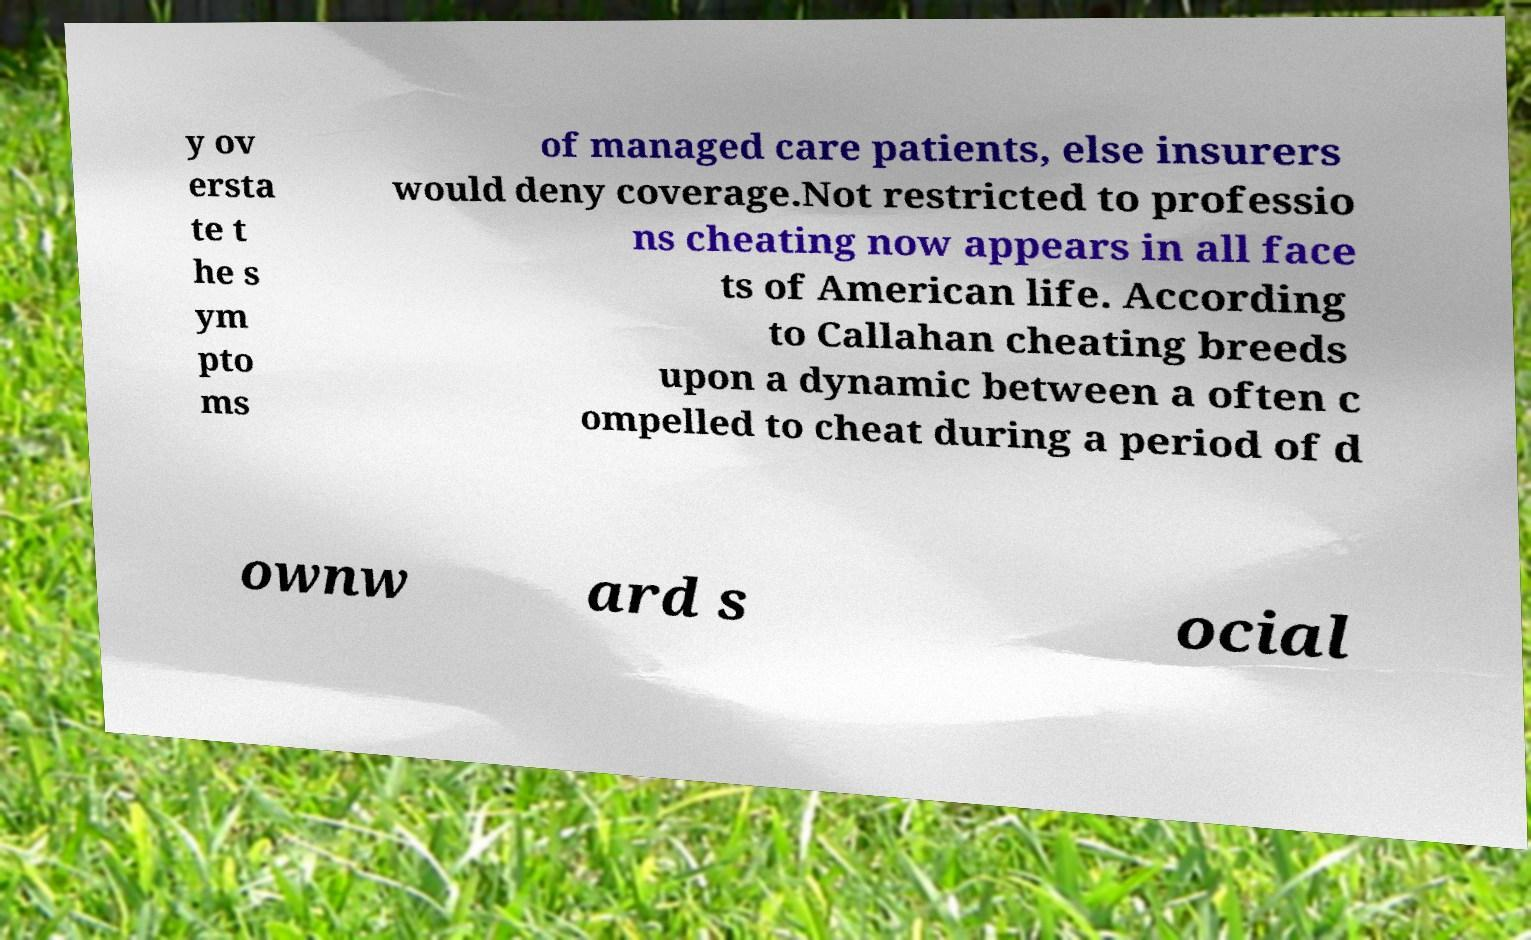Could you extract and type out the text from this image? y ov ersta te t he s ym pto ms of managed care patients, else insurers would deny coverage.Not restricted to professio ns cheating now appears in all face ts of American life. According to Callahan cheating breeds upon a dynamic between a often c ompelled to cheat during a period of d ownw ard s ocial 